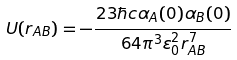<formula> <loc_0><loc_0><loc_500><loc_500>U ( r _ { A B } ) = - \frac { 2 3 \hbar { c } \alpha _ { A } ( 0 ) \alpha _ { B } ( 0 ) } { 6 4 \pi ^ { 3 } \varepsilon _ { 0 } ^ { 2 } r _ { A B } ^ { 7 } }</formula> 